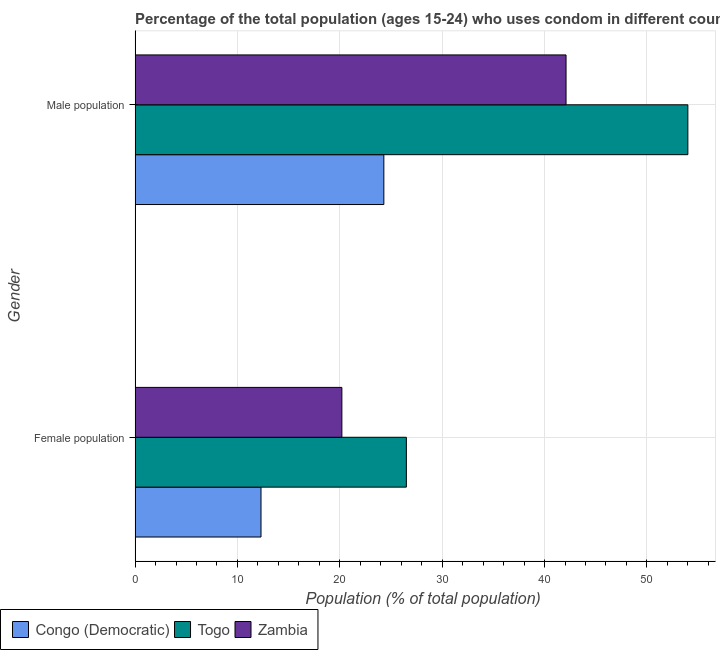How many groups of bars are there?
Ensure brevity in your answer.  2. Are the number of bars per tick equal to the number of legend labels?
Ensure brevity in your answer.  Yes. Are the number of bars on each tick of the Y-axis equal?
Your answer should be compact. Yes. How many bars are there on the 2nd tick from the top?
Your answer should be very brief. 3. What is the label of the 1st group of bars from the top?
Offer a terse response. Male population. Across all countries, what is the maximum female population?
Ensure brevity in your answer.  26.5. Across all countries, what is the minimum female population?
Keep it short and to the point. 12.3. In which country was the male population maximum?
Provide a short and direct response. Togo. In which country was the male population minimum?
Make the answer very short. Congo (Democratic). What is the total male population in the graph?
Your answer should be compact. 120.4. What is the difference between the female population in Congo (Democratic) and that in Togo?
Offer a terse response. -14.2. What is the difference between the female population in Congo (Democratic) and the male population in Zambia?
Offer a very short reply. -29.8. What is the average female population per country?
Give a very brief answer. 19.67. What is the difference between the male population and female population in Congo (Democratic)?
Your answer should be compact. 12. What is the ratio of the female population in Zambia to that in Togo?
Offer a terse response. 0.76. Is the male population in Zambia less than that in Togo?
Offer a very short reply. Yes. In how many countries, is the female population greater than the average female population taken over all countries?
Provide a succinct answer. 2. What does the 1st bar from the top in Female population represents?
Give a very brief answer. Zambia. What does the 2nd bar from the bottom in Male population represents?
Make the answer very short. Togo. How many countries are there in the graph?
Your response must be concise. 3. Does the graph contain grids?
Your answer should be very brief. Yes. How are the legend labels stacked?
Your answer should be very brief. Horizontal. What is the title of the graph?
Make the answer very short. Percentage of the total population (ages 15-24) who uses condom in different countries. What is the label or title of the X-axis?
Keep it short and to the point. Population (% of total population) . What is the label or title of the Y-axis?
Keep it short and to the point. Gender. What is the Population (% of total population)  of Congo (Democratic) in Female population?
Your answer should be compact. 12.3. What is the Population (% of total population)  of Togo in Female population?
Your answer should be compact. 26.5. What is the Population (% of total population)  of Zambia in Female population?
Give a very brief answer. 20.2. What is the Population (% of total population)  of Congo (Democratic) in Male population?
Offer a very short reply. 24.3. What is the Population (% of total population)  in Togo in Male population?
Provide a short and direct response. 54. What is the Population (% of total population)  of Zambia in Male population?
Your answer should be very brief. 42.1. Across all Gender, what is the maximum Population (% of total population)  in Congo (Democratic)?
Your answer should be very brief. 24.3. Across all Gender, what is the maximum Population (% of total population)  in Togo?
Your response must be concise. 54. Across all Gender, what is the maximum Population (% of total population)  in Zambia?
Offer a terse response. 42.1. Across all Gender, what is the minimum Population (% of total population)  of Zambia?
Make the answer very short. 20.2. What is the total Population (% of total population)  of Congo (Democratic) in the graph?
Provide a short and direct response. 36.6. What is the total Population (% of total population)  in Togo in the graph?
Provide a short and direct response. 80.5. What is the total Population (% of total population)  in Zambia in the graph?
Your answer should be very brief. 62.3. What is the difference between the Population (% of total population)  of Togo in Female population and that in Male population?
Ensure brevity in your answer.  -27.5. What is the difference between the Population (% of total population)  in Zambia in Female population and that in Male population?
Offer a terse response. -21.9. What is the difference between the Population (% of total population)  of Congo (Democratic) in Female population and the Population (% of total population)  of Togo in Male population?
Provide a succinct answer. -41.7. What is the difference between the Population (% of total population)  in Congo (Democratic) in Female population and the Population (% of total population)  in Zambia in Male population?
Make the answer very short. -29.8. What is the difference between the Population (% of total population)  of Togo in Female population and the Population (% of total population)  of Zambia in Male population?
Your answer should be very brief. -15.6. What is the average Population (% of total population)  of Togo per Gender?
Your answer should be very brief. 40.25. What is the average Population (% of total population)  in Zambia per Gender?
Offer a very short reply. 31.15. What is the difference between the Population (% of total population)  in Congo (Democratic) and Population (% of total population)  in Zambia in Female population?
Your response must be concise. -7.9. What is the difference between the Population (% of total population)  in Congo (Democratic) and Population (% of total population)  in Togo in Male population?
Provide a succinct answer. -29.7. What is the difference between the Population (% of total population)  of Congo (Democratic) and Population (% of total population)  of Zambia in Male population?
Provide a short and direct response. -17.8. What is the difference between the Population (% of total population)  in Togo and Population (% of total population)  in Zambia in Male population?
Your answer should be compact. 11.9. What is the ratio of the Population (% of total population)  in Congo (Democratic) in Female population to that in Male population?
Provide a succinct answer. 0.51. What is the ratio of the Population (% of total population)  in Togo in Female population to that in Male population?
Ensure brevity in your answer.  0.49. What is the ratio of the Population (% of total population)  of Zambia in Female population to that in Male population?
Your response must be concise. 0.48. What is the difference between the highest and the second highest Population (% of total population)  in Congo (Democratic)?
Your answer should be very brief. 12. What is the difference between the highest and the second highest Population (% of total population)  of Zambia?
Provide a short and direct response. 21.9. What is the difference between the highest and the lowest Population (% of total population)  in Zambia?
Give a very brief answer. 21.9. 